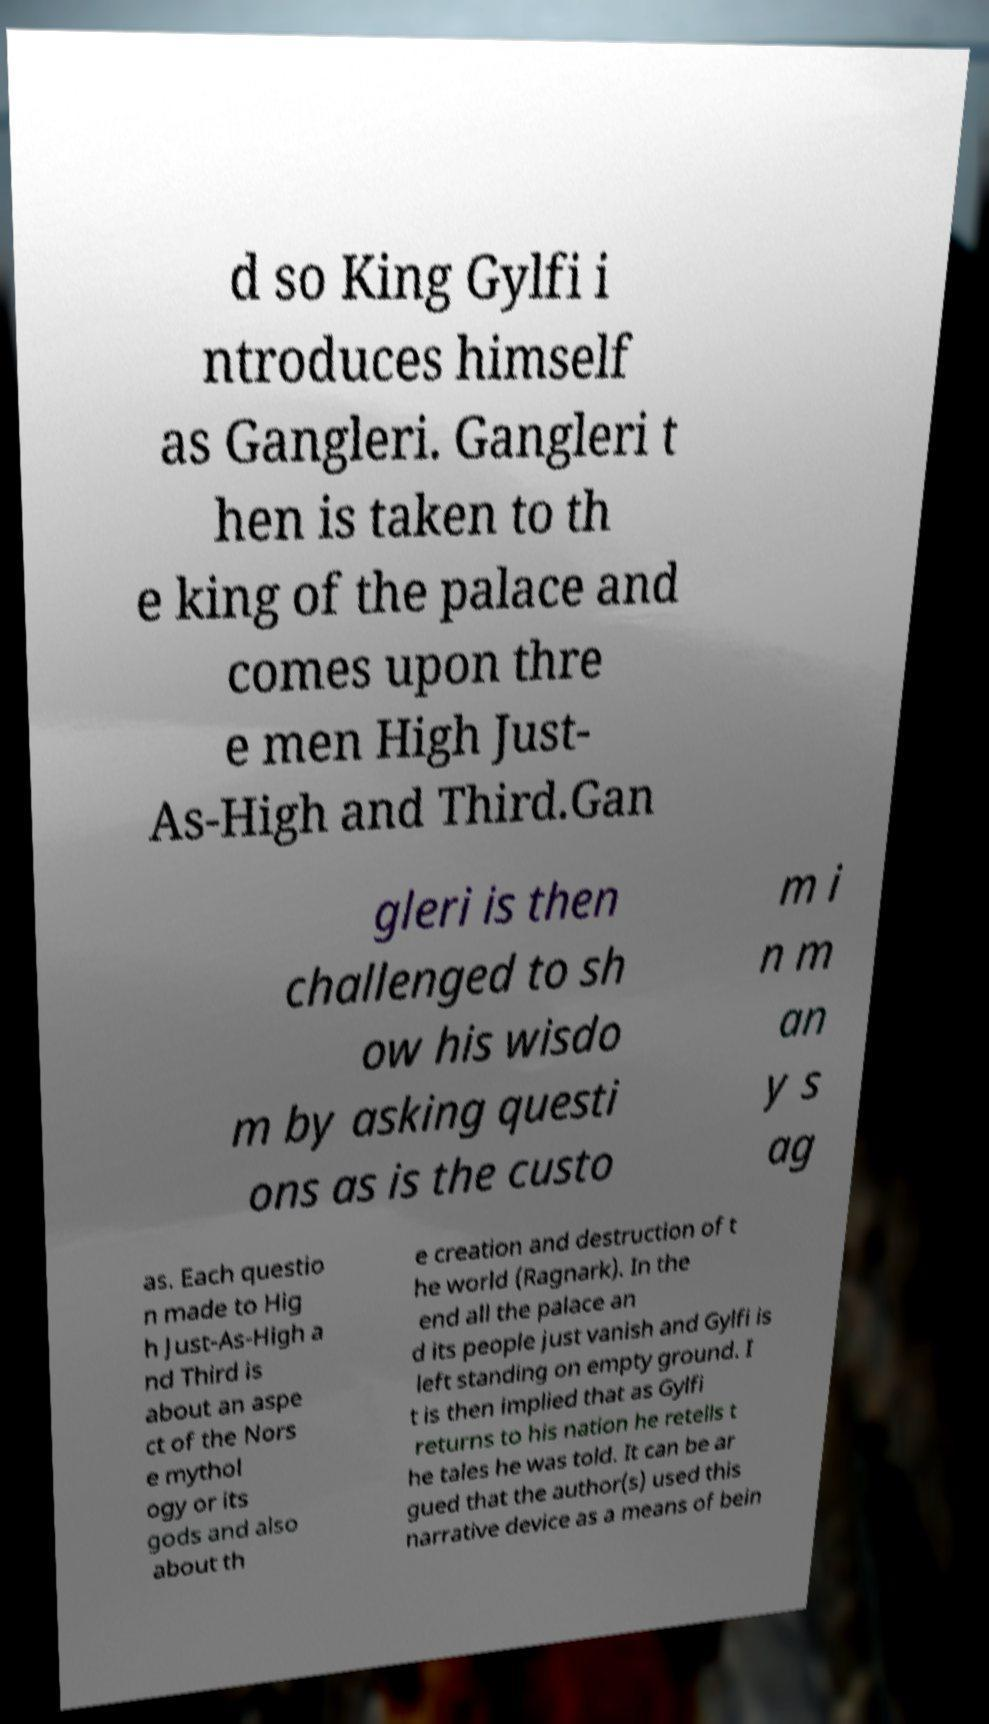Could you extract and type out the text from this image? d so King Gylfi i ntroduces himself as Gangleri. Gangleri t hen is taken to th e king of the palace and comes upon thre e men High Just- As-High and Third.Gan gleri is then challenged to sh ow his wisdo m by asking questi ons as is the custo m i n m an y s ag as. Each questio n made to Hig h Just-As-High a nd Third is about an aspe ct of the Nors e mythol ogy or its gods and also about th e creation and destruction of t he world (Ragnark). In the end all the palace an d its people just vanish and Gylfi is left standing on empty ground. I t is then implied that as Gylfi returns to his nation he retells t he tales he was told. It can be ar gued that the author(s) used this narrative device as a means of bein 